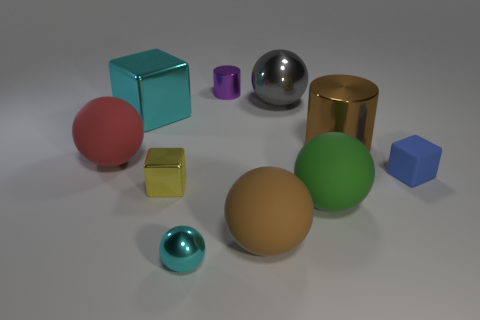Subtract all tiny metal balls. How many balls are left? 4 Subtract all yellow balls. Subtract all purple cubes. How many balls are left? 5 Subtract all blocks. How many objects are left? 7 Subtract 1 green balls. How many objects are left? 9 Subtract all big green shiny spheres. Subtract all big gray metal things. How many objects are left? 9 Add 2 matte balls. How many matte balls are left? 5 Add 1 big shiny cylinders. How many big shiny cylinders exist? 2 